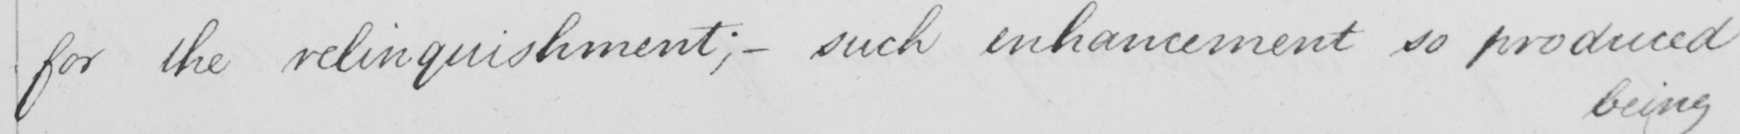What is written in this line of handwriting? for the relinquishment ;  _  such enhancement so produced 